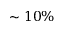<formula> <loc_0><loc_0><loc_500><loc_500>\sim 1 0 \%</formula> 